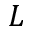<formula> <loc_0><loc_0><loc_500><loc_500>L</formula> 